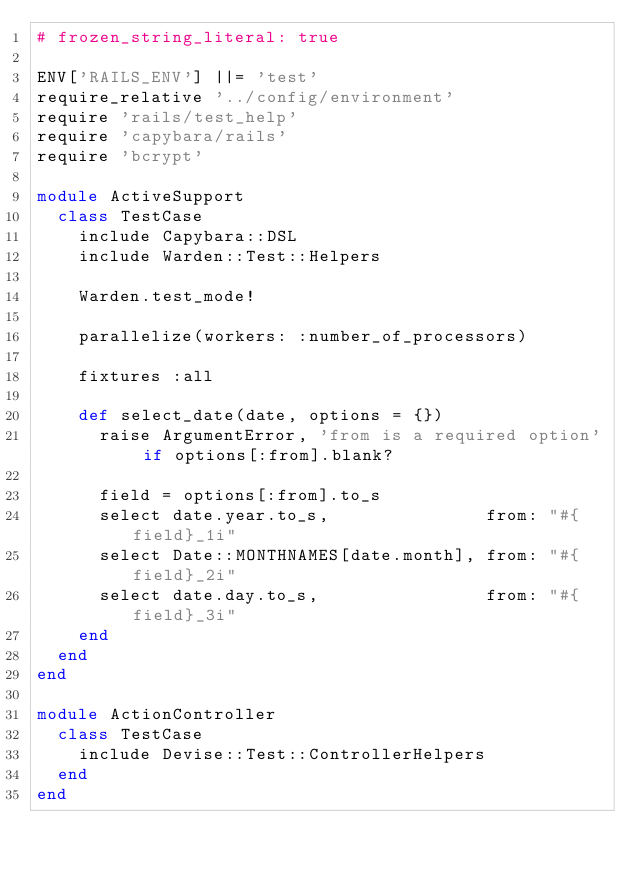Convert code to text. <code><loc_0><loc_0><loc_500><loc_500><_Ruby_># frozen_string_literal: true

ENV['RAILS_ENV'] ||= 'test'
require_relative '../config/environment'
require 'rails/test_help'
require 'capybara/rails'
require 'bcrypt'

module ActiveSupport
  class TestCase
    include Capybara::DSL
    include Warden::Test::Helpers

    Warden.test_mode!

    parallelize(workers: :number_of_processors)

    fixtures :all

    def select_date(date, options = {})
      raise ArgumentError, 'from is a required option' if options[:from].blank?

      field = options[:from].to_s
      select date.year.to_s,               from: "#{field}_1i"
      select Date::MONTHNAMES[date.month], from: "#{field}_2i"
      select date.day.to_s,                from: "#{field}_3i"
    end
  end
end

module ActionController
  class TestCase
    include Devise::Test::ControllerHelpers
  end
end
</code> 